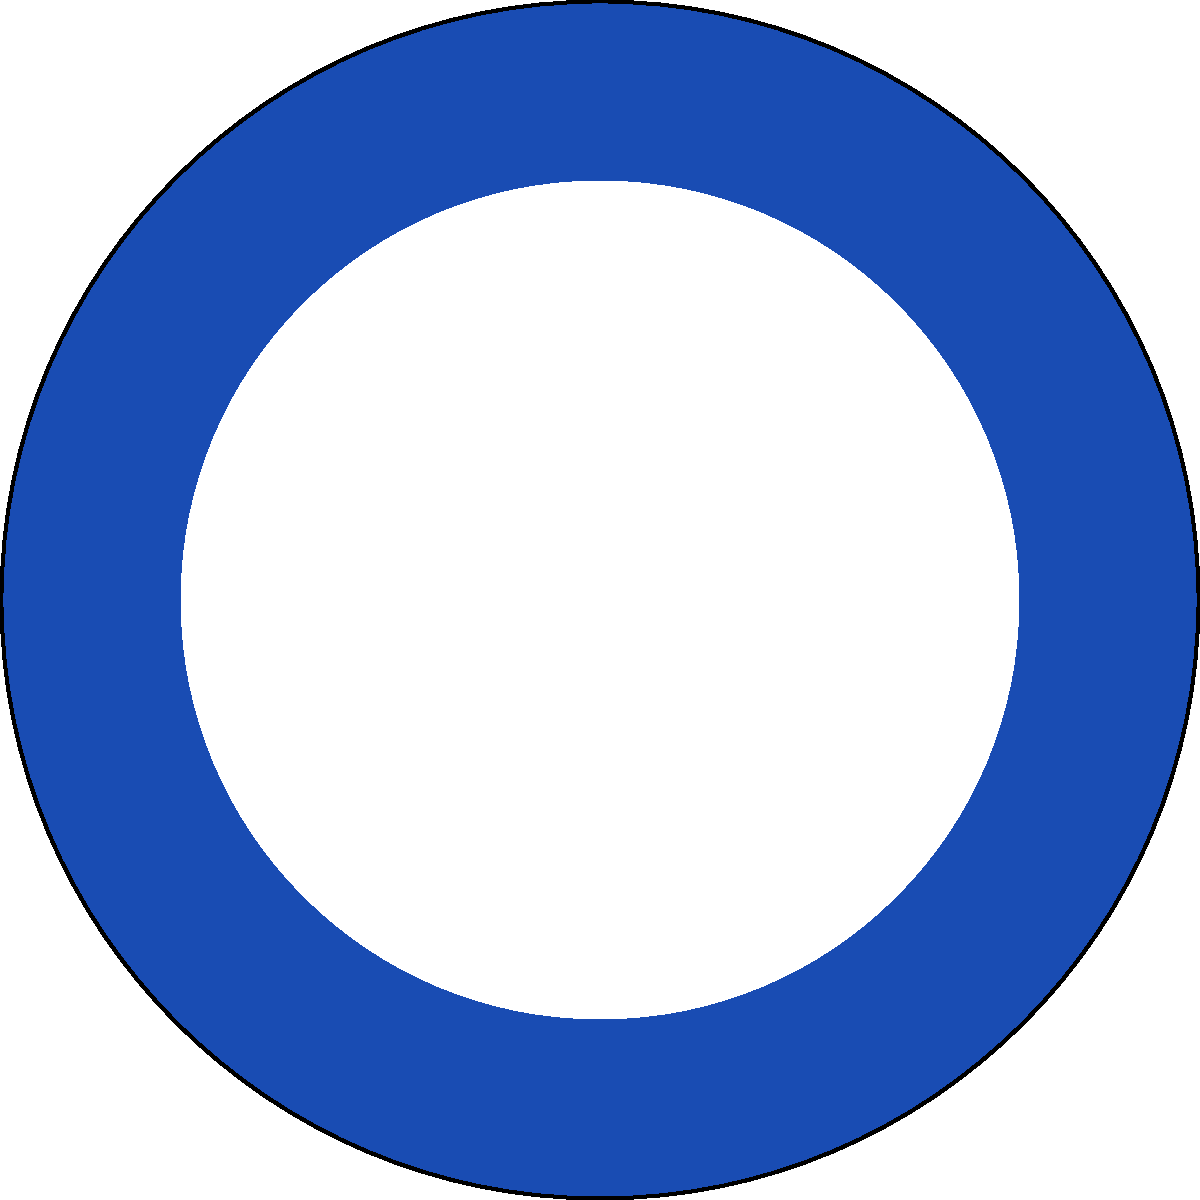As a community leader promoting peace, you're often involved in discussions about international peacekeeping efforts. Which of the flags shown above (A, B, or C) represents the organization primarily responsible for maintaining international peace and security, and is often called upon to prevent conflicts and keep peace around the world? To answer this question, let's examine each flag:

1. Flag A: This is the flag of the United Nations (UN). It features a white world map projection centered on the North Pole, surrounded by olive branches on a light blue background.

2. Flag B: This is the flag of the North Atlantic Treaty Organization (NATO). It has a dark blue background with a white compass rose emblem.

3. Flag C: This is the flag of the Organization for Security and Co-operation in Europe (OSCE). It has a solid dark green background with white text.

The organization primarily responsible for maintaining international peace and security is the United Nations (UN). The UN was founded in 1945 after World War II with the main purpose of maintaining international peace and security, developing friendly relations among nations, and promoting social progress, better living standards, and human rights.

The UN has several bodies dedicated to peacekeeping, including the Security Council and the Department of Peacekeeping Operations. UN peacekeeping operations are deployed to various conflict zones around the world to help countries navigate the difficult path from conflict to peace.

While NATO and the OSCE also contribute to international security in their own ways, the UN has a broader global mandate and is the primary organization called upon for international peacekeeping efforts.

Therefore, the correct answer is Flag A, which represents the United Nations.
Answer: A (United Nations) 